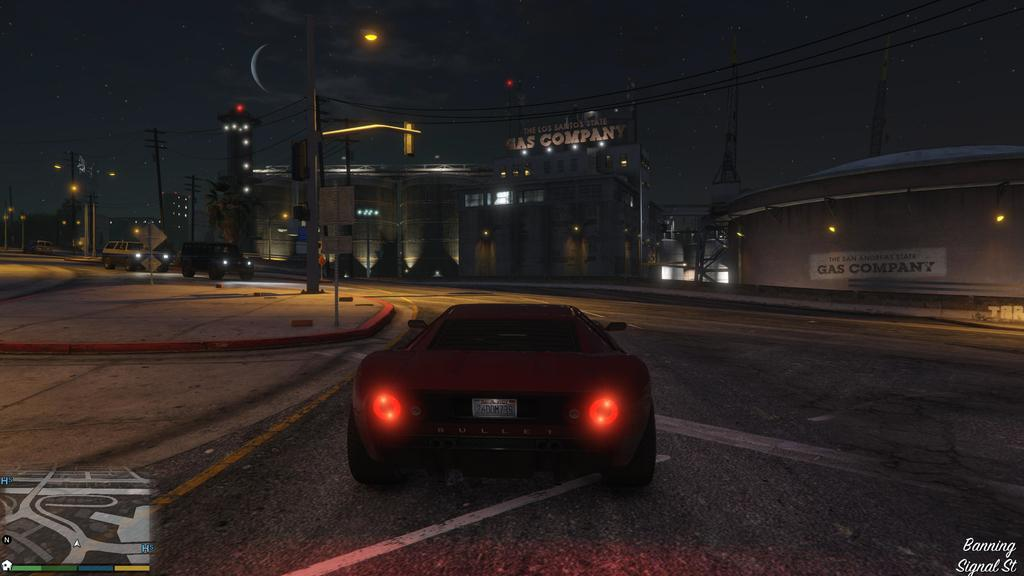What is the main subject of the image? There is a car in the center of the image. Where is the car located? The car is on the road. What can be seen in the background of the image? There are poles with wires and buildings in the background. Are there any other vehicles visible in the image? Yes, there are vehicles on the road in the background. What advice is the car giving to the gate in the image? There is no gate present in the image, and therefore no advice can be given. What is the price of the car in the image? The image does not provide any information about the price of the car. 